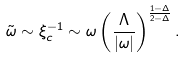<formula> <loc_0><loc_0><loc_500><loc_500>\tilde { \omega } \sim \xi _ { c } ^ { - 1 } \sim \omega \left ( \frac { \Lambda } { | \omega | } \right ) ^ { \frac { 1 - \Delta } { 2 - \Delta } } .</formula> 